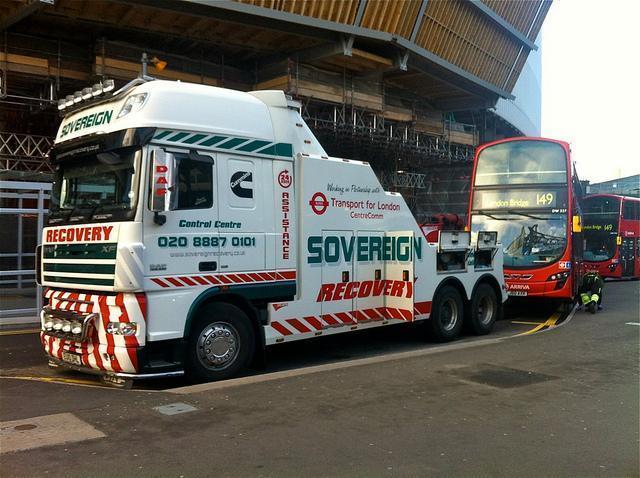Where is Sovereign Recovery located?
Make your selection from the four choices given to correctly answer the question.
Options: St albans, london, st. louis, tuscany. St albans. 